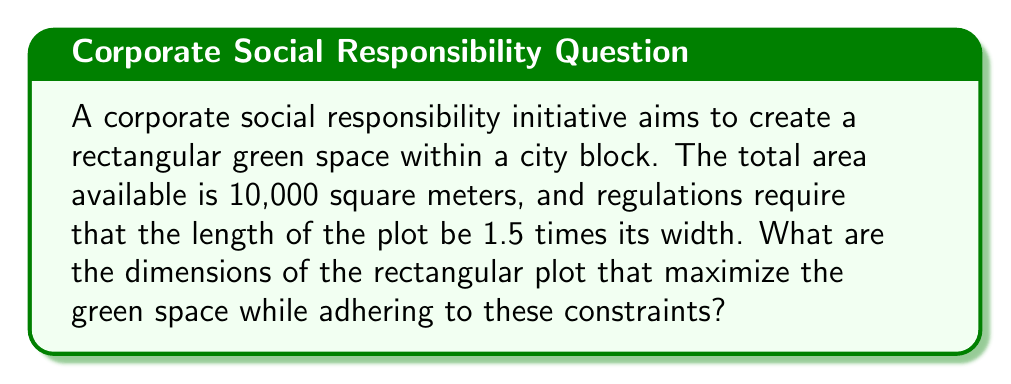Could you help me with this problem? Let's approach this step-by-step:

1) Let the width of the rectangle be $w$ and the length be $l$.

2) Given that the length should be 1.5 times the width:
   $l = 1.5w$

3) The area of a rectangle is given by length times width:
   $A = l \times w$

4) We know the total area is 10,000 square meters:
   $10000 = l \times w$

5) Substituting the relationship between length and width:
   $10000 = 1.5w \times w = 1.5w^2$

6) Solving for $w$:
   $$\begin{align}
   1.5w^2 &= 10000 \\
   w^2 &= \frac{10000}{1.5} \approx 6666.67 \\
   w &= \sqrt{6666.67} \approx 81.65 \text{ meters}
   \end{align}$$

7) Now that we have the width, we can calculate the length:
   $l = 1.5w = 1.5 \times 81.65 \approx 122.47 \text{ meters}$

8) Rounding to two decimal places for practical purposes:
   Width = 81.65 m
   Length = 122.47 m

These dimensions maximize the green space while adhering to the given constraints.
Answer: Width: 81.65 m, Length: 122.47 m 